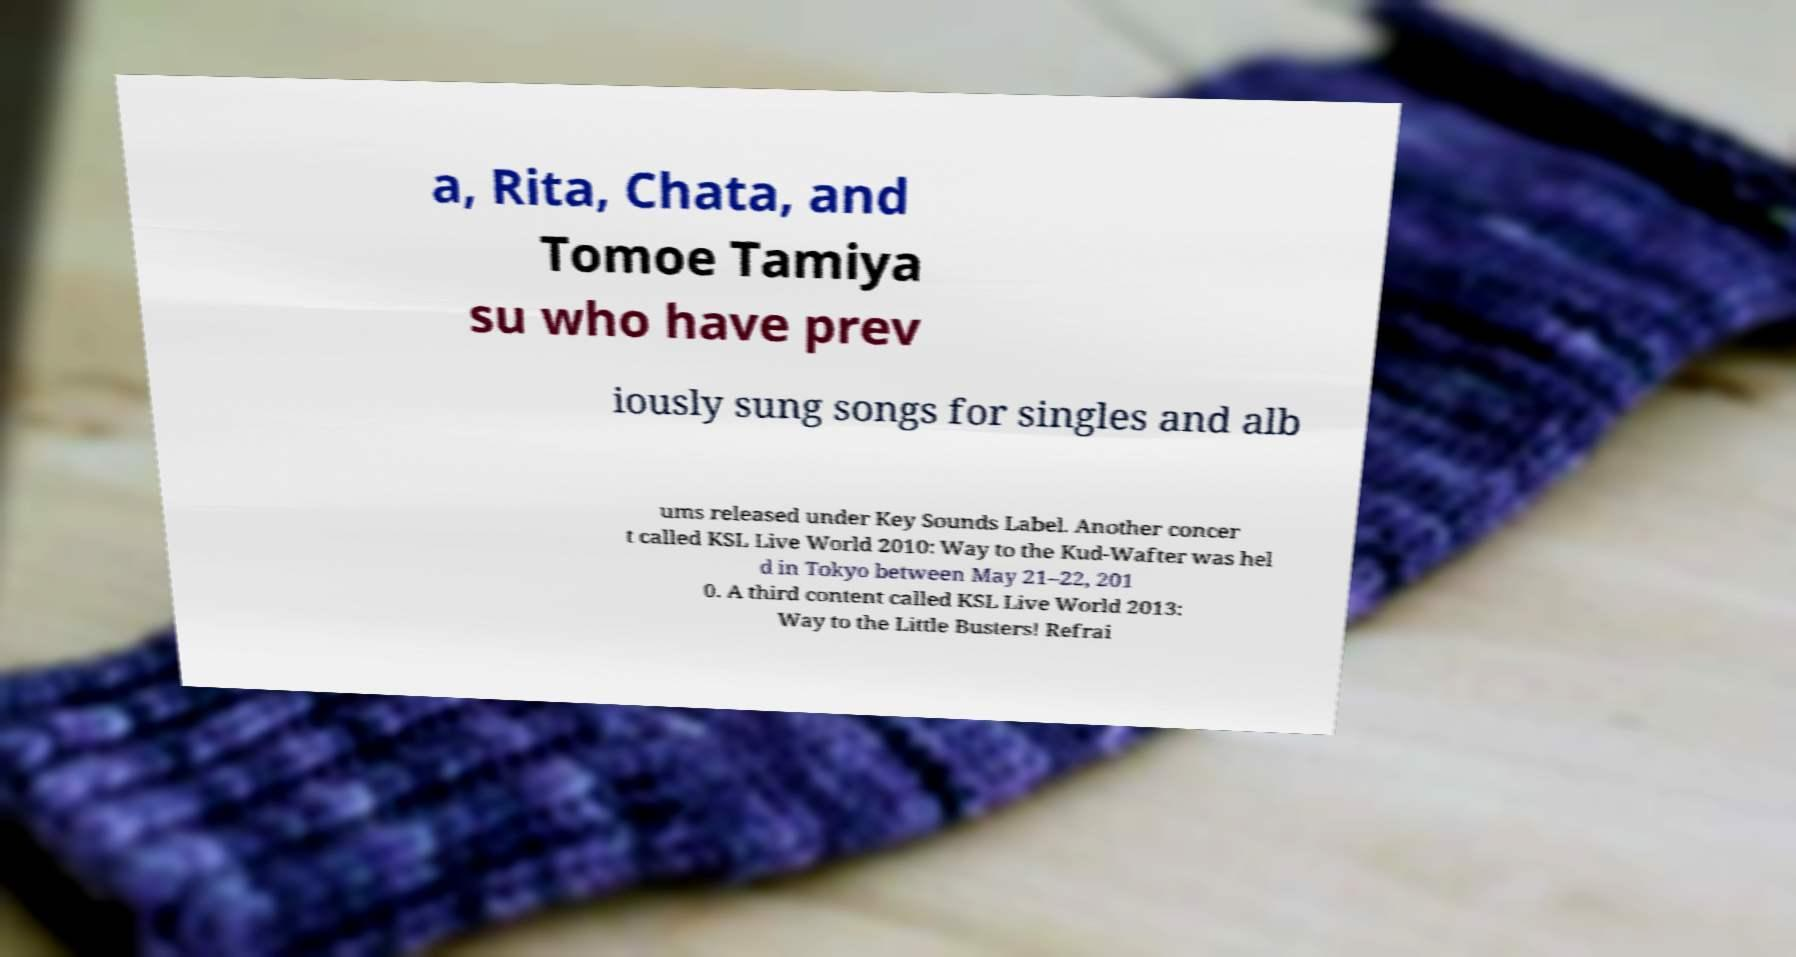Could you assist in decoding the text presented in this image and type it out clearly? a, Rita, Chata, and Tomoe Tamiya su who have prev iously sung songs for singles and alb ums released under Key Sounds Label. Another concer t called KSL Live World 2010: Way to the Kud-Wafter was hel d in Tokyo between May 21–22, 201 0. A third content called KSL Live World 2013: Way to the Little Busters! Refrai 